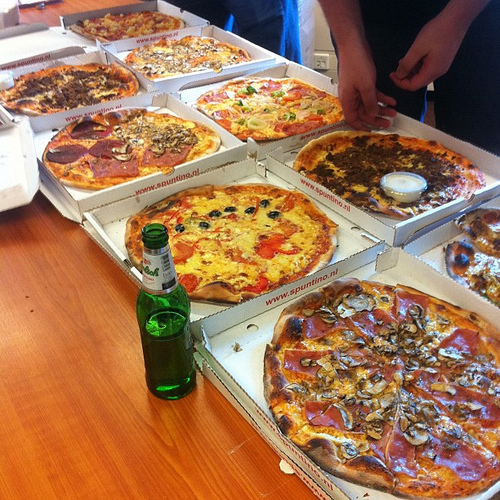What is the food in the white container? The food in the white container is cheese. 